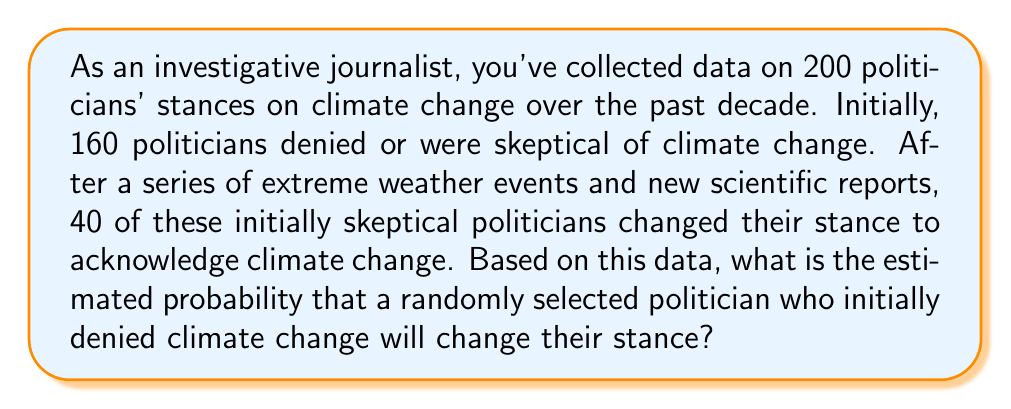Solve this math problem. To solve this problem, we need to use conditional probability. We're looking for the probability of a politician changing their stance, given that they initially denied climate change.

Let's define our events:
A = politician initially denied climate change
B = politician changed their stance

We want to find P(B|A), the probability of B given A.

We can calculate this using the formula:

$$ P(B|A) = \frac{P(B \cap A)}{P(A)} $$

From the given data:
- Total politicians: 200
- Initially skeptical: 160
- Changed stance: 40

1. Calculate P(A):
   $$ P(A) = \frac{160}{200} = 0.8 $$

2. Calculate P(B ∩ A):
   $$ P(B \cap A) = \frac{40}{200} = 0.2 $$

3. Now we can apply the conditional probability formula:
   $$ P(B|A) = \frac{P(B \cap A)}{P(A)} = \frac{0.2}{0.8} = 0.25 $$

Therefore, the estimated probability that a randomly selected politician who initially denied climate change will change their stance is 0.25 or 25%.
Answer: 0.25 or 25% 